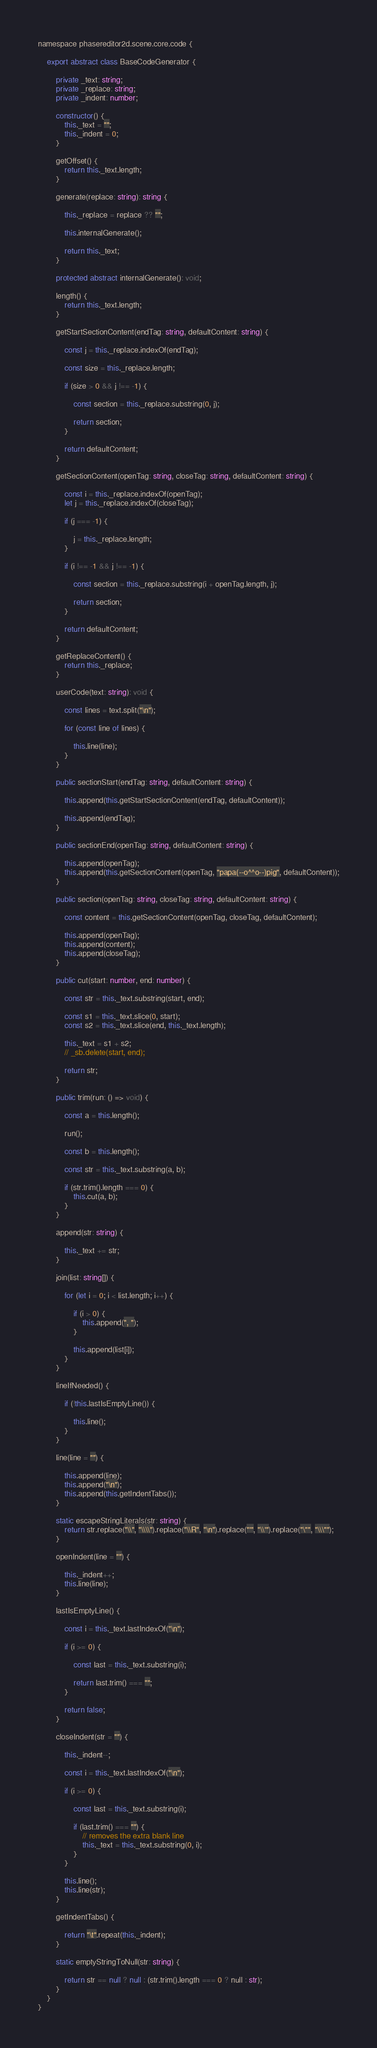<code> <loc_0><loc_0><loc_500><loc_500><_TypeScript_>namespace phasereditor2d.scene.core.code {

    export abstract class BaseCodeGenerator {

        private _text: string;
        private _replace: string;
        private _indent: number;

        constructor() {
            this._text = "";
            this._indent = 0;
        }

        getOffset() {
            return this._text.length;
        }

        generate(replace: string): string {

            this._replace = replace ?? "";

            this.internalGenerate();

            return this._text;
        }

        protected abstract internalGenerate(): void;

        length() {
            return this._text.length;
        }

        getStartSectionContent(endTag: string, defaultContent: string) {

            const j = this._replace.indexOf(endTag);

            const size = this._replace.length;

            if (size > 0 && j !== -1) {

                const section = this._replace.substring(0, j);

                return section;
            }

            return defaultContent;
        }

        getSectionContent(openTag: string, closeTag: string, defaultContent: string) {

            const i = this._replace.indexOf(openTag);
            let j = this._replace.indexOf(closeTag);

            if (j === -1) {

                j = this._replace.length;
            }

            if (i !== -1 && j !== -1) {

                const section = this._replace.substring(i + openTag.length, j);

                return section;
            }

            return defaultContent;
        }

        getReplaceContent() {
            return this._replace;
        }

        userCode(text: string): void {

            const lines = text.split("\n");

            for (const line of lines) {

                this.line(line);
            }
        }

        public sectionStart(endTag: string, defaultContent: string) {

            this.append(this.getStartSectionContent(endTag, defaultContent));

            this.append(endTag);
        }

        public sectionEnd(openTag: string, defaultContent: string) {

            this.append(openTag);
            this.append(this.getSectionContent(openTag, "papa(--o^^o--)pig", defaultContent));
        }

        public section(openTag: string, closeTag: string, defaultContent: string) {

            const content = this.getSectionContent(openTag, closeTag, defaultContent);

            this.append(openTag);
            this.append(content);
            this.append(closeTag);
        }

        public cut(start: number, end: number) {

            const str = this._text.substring(start, end);

            const s1 = this._text.slice(0, start);
            const s2 = this._text.slice(end, this._text.length);

            this._text = s1 + s2;
            // _sb.delete(start, end);

            return str;
        }

        public trim(run: () => void) {

            const a = this.length();

            run();

            const b = this.length();

            const str = this._text.substring(a, b);

            if (str.trim().length === 0) {
                this.cut(a, b);
            }
        }

        append(str: string) {

            this._text += str;
        }

        join(list: string[]) {

            for (let i = 0; i < list.length; i++) {

                if (i > 0) {
                    this.append(", ");
                }

                this.append(list[i]);
            }
        }

        lineIfNeeded() {

            if (!this.lastIsEmptyLine()) {

                this.line();
            }
        }

        line(line = "") {

            this.append(line);
            this.append("\n");
            this.append(this.getIndentTabs());
        }

        static escapeStringLiterals(str: string) {
            return str.replace("\\", "\\\\").replace("\\R", "\n").replace("'", "\\'").replace("\"", "\\\"");
        }

        openIndent(line = "") {

            this._indent++;
            this.line(line);
        }

        lastIsEmptyLine() {

            const i = this._text.lastIndexOf("\n");

            if (i >= 0) {

                const last = this._text.substring(i);

                return last.trim() === "";
            }

            return false;
        }

        closeIndent(str = "") {

            this._indent--;

            const i = this._text.lastIndexOf("\n");

            if (i >= 0) {

                const last = this._text.substring(i);

                if (last.trim() === "") {
                    // removes the extra blank line
                    this._text = this._text.substring(0, i);
                }
            }

            this.line();
            this.line(str);
        }

        getIndentTabs() {

            return "\t".repeat(this._indent);
        }

        static emptyStringToNull(str: string) {

            return str == null ? null : (str.trim().length === 0 ? null : str);
        }
    }
}</code> 